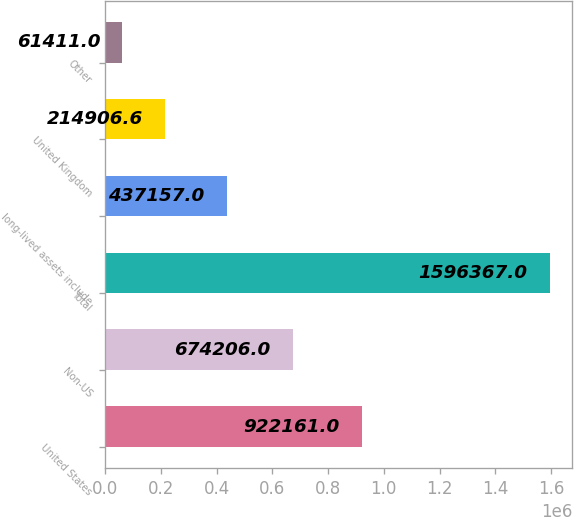Convert chart to OTSL. <chart><loc_0><loc_0><loc_500><loc_500><bar_chart><fcel>United States<fcel>Non-US<fcel>Total<fcel>long-lived assets include<fcel>United Kingdom<fcel>Other<nl><fcel>922161<fcel>674206<fcel>1.59637e+06<fcel>437157<fcel>214907<fcel>61411<nl></chart> 